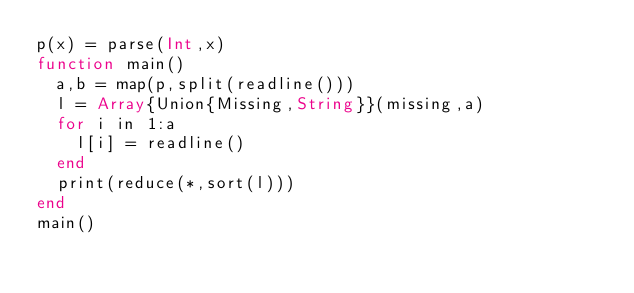<code> <loc_0><loc_0><loc_500><loc_500><_Julia_>p(x) = parse(Int,x)
function main()
  a,b = map(p,split(readline()))
  l = Array{Union{Missing,String}}(missing,a)
  for i in 1:a
    l[i] = readline()
  end
  print(reduce(*,sort(l)))
end
main()</code> 